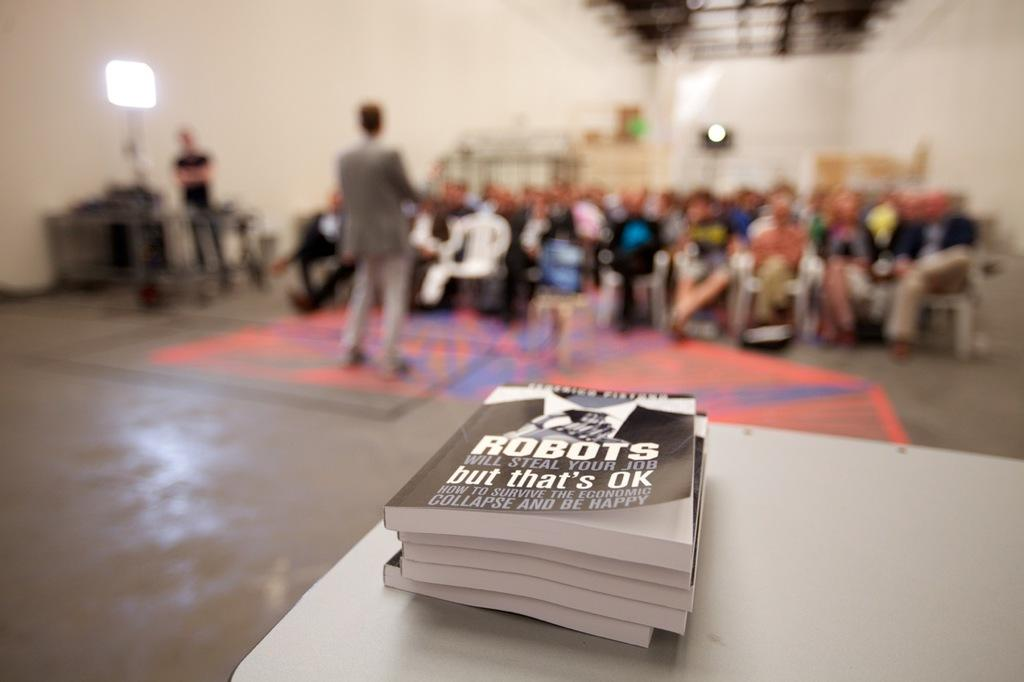<image>
Provide a brief description of the given image. A white table has a stack of books named ROBOTS WILL STEAL YOUR JOB. 